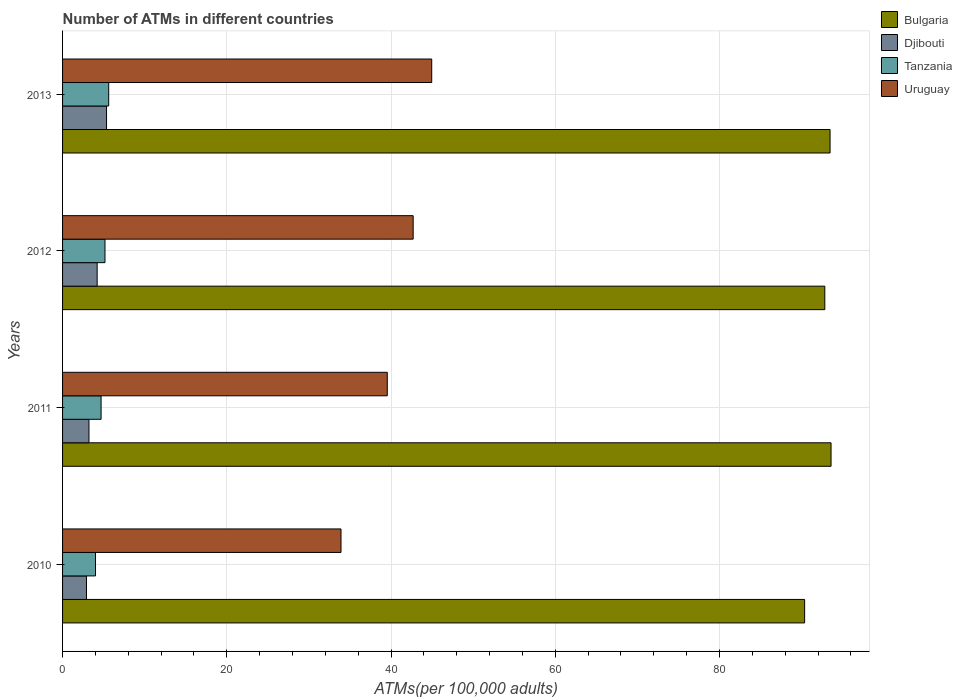How many different coloured bars are there?
Provide a short and direct response. 4. How many groups of bars are there?
Offer a very short reply. 4. Are the number of bars per tick equal to the number of legend labels?
Keep it short and to the point. Yes. What is the label of the 4th group of bars from the top?
Provide a short and direct response. 2010. What is the number of ATMs in Bulgaria in 2013?
Keep it short and to the point. 93.46. Across all years, what is the maximum number of ATMs in Bulgaria?
Make the answer very short. 93.58. Across all years, what is the minimum number of ATMs in Djibouti?
Offer a terse response. 2.91. In which year was the number of ATMs in Uruguay maximum?
Ensure brevity in your answer.  2013. In which year was the number of ATMs in Uruguay minimum?
Offer a terse response. 2010. What is the total number of ATMs in Djibouti in the graph?
Keep it short and to the point. 15.7. What is the difference between the number of ATMs in Djibouti in 2011 and that in 2012?
Make the answer very short. -1. What is the difference between the number of ATMs in Bulgaria in 2010 and the number of ATMs in Djibouti in 2011?
Your answer should be very brief. 87.15. What is the average number of ATMs in Tanzania per year?
Your answer should be compact. 4.87. In the year 2010, what is the difference between the number of ATMs in Bulgaria and number of ATMs in Djibouti?
Offer a very short reply. 87.45. In how many years, is the number of ATMs in Uruguay greater than 40 ?
Your answer should be very brief. 2. What is the ratio of the number of ATMs in Uruguay in 2012 to that in 2013?
Make the answer very short. 0.95. Is the number of ATMs in Bulgaria in 2012 less than that in 2013?
Keep it short and to the point. Yes. Is the difference between the number of ATMs in Bulgaria in 2012 and 2013 greater than the difference between the number of ATMs in Djibouti in 2012 and 2013?
Offer a terse response. Yes. What is the difference between the highest and the second highest number of ATMs in Bulgaria?
Offer a very short reply. 0.12. What is the difference between the highest and the lowest number of ATMs in Tanzania?
Offer a very short reply. 1.61. Is the sum of the number of ATMs in Tanzania in 2012 and 2013 greater than the maximum number of ATMs in Djibouti across all years?
Make the answer very short. Yes. Is it the case that in every year, the sum of the number of ATMs in Uruguay and number of ATMs in Djibouti is greater than the sum of number of ATMs in Bulgaria and number of ATMs in Tanzania?
Your answer should be very brief. Yes. What does the 1st bar from the top in 2013 represents?
Keep it short and to the point. Uruguay. How many bars are there?
Keep it short and to the point. 16. How many years are there in the graph?
Keep it short and to the point. 4. Are the values on the major ticks of X-axis written in scientific E-notation?
Offer a terse response. No. Where does the legend appear in the graph?
Make the answer very short. Top right. What is the title of the graph?
Offer a very short reply. Number of ATMs in different countries. What is the label or title of the X-axis?
Your response must be concise. ATMs(per 100,0 adults). What is the label or title of the Y-axis?
Make the answer very short. Years. What is the ATMs(per 100,000 adults) of Bulgaria in 2010?
Make the answer very short. 90.36. What is the ATMs(per 100,000 adults) of Djibouti in 2010?
Your response must be concise. 2.91. What is the ATMs(per 100,000 adults) in Tanzania in 2010?
Offer a very short reply. 4.01. What is the ATMs(per 100,000 adults) of Uruguay in 2010?
Offer a very short reply. 33.91. What is the ATMs(per 100,000 adults) of Bulgaria in 2011?
Give a very brief answer. 93.58. What is the ATMs(per 100,000 adults) of Djibouti in 2011?
Offer a very short reply. 3.21. What is the ATMs(per 100,000 adults) in Tanzania in 2011?
Your answer should be compact. 4.69. What is the ATMs(per 100,000 adults) of Uruguay in 2011?
Give a very brief answer. 39.54. What is the ATMs(per 100,000 adults) of Bulgaria in 2012?
Your response must be concise. 92.82. What is the ATMs(per 100,000 adults) in Djibouti in 2012?
Offer a terse response. 4.21. What is the ATMs(per 100,000 adults) of Tanzania in 2012?
Offer a terse response. 5.16. What is the ATMs(per 100,000 adults) in Uruguay in 2012?
Give a very brief answer. 42.69. What is the ATMs(per 100,000 adults) in Bulgaria in 2013?
Make the answer very short. 93.46. What is the ATMs(per 100,000 adults) in Djibouti in 2013?
Your answer should be very brief. 5.36. What is the ATMs(per 100,000 adults) of Tanzania in 2013?
Give a very brief answer. 5.62. What is the ATMs(per 100,000 adults) in Uruguay in 2013?
Your answer should be compact. 44.95. Across all years, what is the maximum ATMs(per 100,000 adults) in Bulgaria?
Your answer should be very brief. 93.58. Across all years, what is the maximum ATMs(per 100,000 adults) in Djibouti?
Your answer should be very brief. 5.36. Across all years, what is the maximum ATMs(per 100,000 adults) of Tanzania?
Make the answer very short. 5.62. Across all years, what is the maximum ATMs(per 100,000 adults) of Uruguay?
Provide a succinct answer. 44.95. Across all years, what is the minimum ATMs(per 100,000 adults) in Bulgaria?
Offer a very short reply. 90.36. Across all years, what is the minimum ATMs(per 100,000 adults) of Djibouti?
Your response must be concise. 2.91. Across all years, what is the minimum ATMs(per 100,000 adults) in Tanzania?
Your answer should be compact. 4.01. Across all years, what is the minimum ATMs(per 100,000 adults) in Uruguay?
Provide a short and direct response. 33.91. What is the total ATMs(per 100,000 adults) of Bulgaria in the graph?
Offer a terse response. 370.24. What is the total ATMs(per 100,000 adults) of Djibouti in the graph?
Provide a short and direct response. 15.7. What is the total ATMs(per 100,000 adults) in Tanzania in the graph?
Make the answer very short. 19.48. What is the total ATMs(per 100,000 adults) in Uruguay in the graph?
Your answer should be very brief. 161.1. What is the difference between the ATMs(per 100,000 adults) of Bulgaria in 2010 and that in 2011?
Offer a terse response. -3.22. What is the difference between the ATMs(per 100,000 adults) of Djibouti in 2010 and that in 2011?
Ensure brevity in your answer.  -0.3. What is the difference between the ATMs(per 100,000 adults) of Tanzania in 2010 and that in 2011?
Your answer should be very brief. -0.68. What is the difference between the ATMs(per 100,000 adults) in Uruguay in 2010 and that in 2011?
Make the answer very short. -5.64. What is the difference between the ATMs(per 100,000 adults) of Bulgaria in 2010 and that in 2012?
Offer a very short reply. -2.46. What is the difference between the ATMs(per 100,000 adults) in Djibouti in 2010 and that in 2012?
Provide a succinct answer. -1.3. What is the difference between the ATMs(per 100,000 adults) of Tanzania in 2010 and that in 2012?
Ensure brevity in your answer.  -1.15. What is the difference between the ATMs(per 100,000 adults) in Uruguay in 2010 and that in 2012?
Your answer should be very brief. -8.79. What is the difference between the ATMs(per 100,000 adults) of Bulgaria in 2010 and that in 2013?
Provide a short and direct response. -3.1. What is the difference between the ATMs(per 100,000 adults) in Djibouti in 2010 and that in 2013?
Provide a succinct answer. -2.44. What is the difference between the ATMs(per 100,000 adults) in Tanzania in 2010 and that in 2013?
Provide a succinct answer. -1.61. What is the difference between the ATMs(per 100,000 adults) of Uruguay in 2010 and that in 2013?
Provide a succinct answer. -11.05. What is the difference between the ATMs(per 100,000 adults) of Bulgaria in 2011 and that in 2012?
Provide a succinct answer. 0.76. What is the difference between the ATMs(per 100,000 adults) of Djibouti in 2011 and that in 2012?
Provide a succinct answer. -1. What is the difference between the ATMs(per 100,000 adults) in Tanzania in 2011 and that in 2012?
Offer a very short reply. -0.47. What is the difference between the ATMs(per 100,000 adults) in Uruguay in 2011 and that in 2012?
Provide a short and direct response. -3.15. What is the difference between the ATMs(per 100,000 adults) of Bulgaria in 2011 and that in 2013?
Your answer should be very brief. 0.12. What is the difference between the ATMs(per 100,000 adults) of Djibouti in 2011 and that in 2013?
Your answer should be very brief. -2.14. What is the difference between the ATMs(per 100,000 adults) of Tanzania in 2011 and that in 2013?
Give a very brief answer. -0.93. What is the difference between the ATMs(per 100,000 adults) in Uruguay in 2011 and that in 2013?
Make the answer very short. -5.41. What is the difference between the ATMs(per 100,000 adults) of Bulgaria in 2012 and that in 2013?
Provide a succinct answer. -0.64. What is the difference between the ATMs(per 100,000 adults) in Djibouti in 2012 and that in 2013?
Ensure brevity in your answer.  -1.14. What is the difference between the ATMs(per 100,000 adults) in Tanzania in 2012 and that in 2013?
Make the answer very short. -0.45. What is the difference between the ATMs(per 100,000 adults) in Uruguay in 2012 and that in 2013?
Your answer should be very brief. -2.26. What is the difference between the ATMs(per 100,000 adults) of Bulgaria in 2010 and the ATMs(per 100,000 adults) of Djibouti in 2011?
Give a very brief answer. 87.15. What is the difference between the ATMs(per 100,000 adults) in Bulgaria in 2010 and the ATMs(per 100,000 adults) in Tanzania in 2011?
Keep it short and to the point. 85.67. What is the difference between the ATMs(per 100,000 adults) of Bulgaria in 2010 and the ATMs(per 100,000 adults) of Uruguay in 2011?
Offer a terse response. 50.82. What is the difference between the ATMs(per 100,000 adults) in Djibouti in 2010 and the ATMs(per 100,000 adults) in Tanzania in 2011?
Your response must be concise. -1.78. What is the difference between the ATMs(per 100,000 adults) in Djibouti in 2010 and the ATMs(per 100,000 adults) in Uruguay in 2011?
Give a very brief answer. -36.63. What is the difference between the ATMs(per 100,000 adults) in Tanzania in 2010 and the ATMs(per 100,000 adults) in Uruguay in 2011?
Your answer should be very brief. -35.53. What is the difference between the ATMs(per 100,000 adults) of Bulgaria in 2010 and the ATMs(per 100,000 adults) of Djibouti in 2012?
Your answer should be very brief. 86.15. What is the difference between the ATMs(per 100,000 adults) in Bulgaria in 2010 and the ATMs(per 100,000 adults) in Tanzania in 2012?
Offer a terse response. 85.2. What is the difference between the ATMs(per 100,000 adults) of Bulgaria in 2010 and the ATMs(per 100,000 adults) of Uruguay in 2012?
Your response must be concise. 47.67. What is the difference between the ATMs(per 100,000 adults) in Djibouti in 2010 and the ATMs(per 100,000 adults) in Tanzania in 2012?
Offer a terse response. -2.25. What is the difference between the ATMs(per 100,000 adults) of Djibouti in 2010 and the ATMs(per 100,000 adults) of Uruguay in 2012?
Your answer should be compact. -39.78. What is the difference between the ATMs(per 100,000 adults) in Tanzania in 2010 and the ATMs(per 100,000 adults) in Uruguay in 2012?
Your answer should be very brief. -38.68. What is the difference between the ATMs(per 100,000 adults) of Bulgaria in 2010 and the ATMs(per 100,000 adults) of Djibouti in 2013?
Make the answer very short. 85.01. What is the difference between the ATMs(per 100,000 adults) in Bulgaria in 2010 and the ATMs(per 100,000 adults) in Tanzania in 2013?
Provide a short and direct response. 84.75. What is the difference between the ATMs(per 100,000 adults) of Bulgaria in 2010 and the ATMs(per 100,000 adults) of Uruguay in 2013?
Your response must be concise. 45.41. What is the difference between the ATMs(per 100,000 adults) in Djibouti in 2010 and the ATMs(per 100,000 adults) in Tanzania in 2013?
Your response must be concise. -2.71. What is the difference between the ATMs(per 100,000 adults) in Djibouti in 2010 and the ATMs(per 100,000 adults) in Uruguay in 2013?
Make the answer very short. -42.04. What is the difference between the ATMs(per 100,000 adults) of Tanzania in 2010 and the ATMs(per 100,000 adults) of Uruguay in 2013?
Make the answer very short. -40.94. What is the difference between the ATMs(per 100,000 adults) in Bulgaria in 2011 and the ATMs(per 100,000 adults) in Djibouti in 2012?
Give a very brief answer. 89.37. What is the difference between the ATMs(per 100,000 adults) of Bulgaria in 2011 and the ATMs(per 100,000 adults) of Tanzania in 2012?
Give a very brief answer. 88.42. What is the difference between the ATMs(per 100,000 adults) in Bulgaria in 2011 and the ATMs(per 100,000 adults) in Uruguay in 2012?
Offer a terse response. 50.89. What is the difference between the ATMs(per 100,000 adults) in Djibouti in 2011 and the ATMs(per 100,000 adults) in Tanzania in 2012?
Give a very brief answer. -1.95. What is the difference between the ATMs(per 100,000 adults) in Djibouti in 2011 and the ATMs(per 100,000 adults) in Uruguay in 2012?
Keep it short and to the point. -39.48. What is the difference between the ATMs(per 100,000 adults) of Tanzania in 2011 and the ATMs(per 100,000 adults) of Uruguay in 2012?
Your answer should be very brief. -38. What is the difference between the ATMs(per 100,000 adults) of Bulgaria in 2011 and the ATMs(per 100,000 adults) of Djibouti in 2013?
Your answer should be compact. 88.23. What is the difference between the ATMs(per 100,000 adults) in Bulgaria in 2011 and the ATMs(per 100,000 adults) in Tanzania in 2013?
Offer a very short reply. 87.97. What is the difference between the ATMs(per 100,000 adults) in Bulgaria in 2011 and the ATMs(per 100,000 adults) in Uruguay in 2013?
Make the answer very short. 48.63. What is the difference between the ATMs(per 100,000 adults) of Djibouti in 2011 and the ATMs(per 100,000 adults) of Tanzania in 2013?
Ensure brevity in your answer.  -2.4. What is the difference between the ATMs(per 100,000 adults) in Djibouti in 2011 and the ATMs(per 100,000 adults) in Uruguay in 2013?
Your response must be concise. -41.74. What is the difference between the ATMs(per 100,000 adults) in Tanzania in 2011 and the ATMs(per 100,000 adults) in Uruguay in 2013?
Make the answer very short. -40.26. What is the difference between the ATMs(per 100,000 adults) of Bulgaria in 2012 and the ATMs(per 100,000 adults) of Djibouti in 2013?
Offer a very short reply. 87.47. What is the difference between the ATMs(per 100,000 adults) of Bulgaria in 2012 and the ATMs(per 100,000 adults) of Tanzania in 2013?
Ensure brevity in your answer.  87.21. What is the difference between the ATMs(per 100,000 adults) in Bulgaria in 2012 and the ATMs(per 100,000 adults) in Uruguay in 2013?
Provide a succinct answer. 47.87. What is the difference between the ATMs(per 100,000 adults) in Djibouti in 2012 and the ATMs(per 100,000 adults) in Tanzania in 2013?
Provide a succinct answer. -1.41. What is the difference between the ATMs(per 100,000 adults) of Djibouti in 2012 and the ATMs(per 100,000 adults) of Uruguay in 2013?
Offer a very short reply. -40.74. What is the difference between the ATMs(per 100,000 adults) of Tanzania in 2012 and the ATMs(per 100,000 adults) of Uruguay in 2013?
Make the answer very short. -39.79. What is the average ATMs(per 100,000 adults) in Bulgaria per year?
Keep it short and to the point. 92.56. What is the average ATMs(per 100,000 adults) of Djibouti per year?
Your answer should be very brief. 3.92. What is the average ATMs(per 100,000 adults) in Tanzania per year?
Give a very brief answer. 4.87. What is the average ATMs(per 100,000 adults) in Uruguay per year?
Your response must be concise. 40.27. In the year 2010, what is the difference between the ATMs(per 100,000 adults) in Bulgaria and ATMs(per 100,000 adults) in Djibouti?
Your answer should be compact. 87.45. In the year 2010, what is the difference between the ATMs(per 100,000 adults) of Bulgaria and ATMs(per 100,000 adults) of Tanzania?
Provide a short and direct response. 86.35. In the year 2010, what is the difference between the ATMs(per 100,000 adults) in Bulgaria and ATMs(per 100,000 adults) in Uruguay?
Provide a short and direct response. 56.46. In the year 2010, what is the difference between the ATMs(per 100,000 adults) of Djibouti and ATMs(per 100,000 adults) of Tanzania?
Offer a very short reply. -1.1. In the year 2010, what is the difference between the ATMs(per 100,000 adults) of Djibouti and ATMs(per 100,000 adults) of Uruguay?
Make the answer very short. -30.99. In the year 2010, what is the difference between the ATMs(per 100,000 adults) of Tanzania and ATMs(per 100,000 adults) of Uruguay?
Your response must be concise. -29.9. In the year 2011, what is the difference between the ATMs(per 100,000 adults) of Bulgaria and ATMs(per 100,000 adults) of Djibouti?
Ensure brevity in your answer.  90.37. In the year 2011, what is the difference between the ATMs(per 100,000 adults) of Bulgaria and ATMs(per 100,000 adults) of Tanzania?
Your response must be concise. 88.89. In the year 2011, what is the difference between the ATMs(per 100,000 adults) in Bulgaria and ATMs(per 100,000 adults) in Uruguay?
Provide a succinct answer. 54.04. In the year 2011, what is the difference between the ATMs(per 100,000 adults) of Djibouti and ATMs(per 100,000 adults) of Tanzania?
Make the answer very short. -1.48. In the year 2011, what is the difference between the ATMs(per 100,000 adults) in Djibouti and ATMs(per 100,000 adults) in Uruguay?
Offer a terse response. -36.33. In the year 2011, what is the difference between the ATMs(per 100,000 adults) in Tanzania and ATMs(per 100,000 adults) in Uruguay?
Give a very brief answer. -34.85. In the year 2012, what is the difference between the ATMs(per 100,000 adults) in Bulgaria and ATMs(per 100,000 adults) in Djibouti?
Your answer should be very brief. 88.61. In the year 2012, what is the difference between the ATMs(per 100,000 adults) of Bulgaria and ATMs(per 100,000 adults) of Tanzania?
Ensure brevity in your answer.  87.66. In the year 2012, what is the difference between the ATMs(per 100,000 adults) of Bulgaria and ATMs(per 100,000 adults) of Uruguay?
Ensure brevity in your answer.  50.13. In the year 2012, what is the difference between the ATMs(per 100,000 adults) of Djibouti and ATMs(per 100,000 adults) of Tanzania?
Your answer should be very brief. -0.95. In the year 2012, what is the difference between the ATMs(per 100,000 adults) of Djibouti and ATMs(per 100,000 adults) of Uruguay?
Give a very brief answer. -38.48. In the year 2012, what is the difference between the ATMs(per 100,000 adults) of Tanzania and ATMs(per 100,000 adults) of Uruguay?
Provide a succinct answer. -37.53. In the year 2013, what is the difference between the ATMs(per 100,000 adults) of Bulgaria and ATMs(per 100,000 adults) of Djibouti?
Give a very brief answer. 88.11. In the year 2013, what is the difference between the ATMs(per 100,000 adults) of Bulgaria and ATMs(per 100,000 adults) of Tanzania?
Keep it short and to the point. 87.85. In the year 2013, what is the difference between the ATMs(per 100,000 adults) in Bulgaria and ATMs(per 100,000 adults) in Uruguay?
Keep it short and to the point. 48.51. In the year 2013, what is the difference between the ATMs(per 100,000 adults) of Djibouti and ATMs(per 100,000 adults) of Tanzania?
Ensure brevity in your answer.  -0.26. In the year 2013, what is the difference between the ATMs(per 100,000 adults) of Djibouti and ATMs(per 100,000 adults) of Uruguay?
Offer a very short reply. -39.6. In the year 2013, what is the difference between the ATMs(per 100,000 adults) in Tanzania and ATMs(per 100,000 adults) in Uruguay?
Offer a very short reply. -39.34. What is the ratio of the ATMs(per 100,000 adults) in Bulgaria in 2010 to that in 2011?
Your answer should be compact. 0.97. What is the ratio of the ATMs(per 100,000 adults) in Djibouti in 2010 to that in 2011?
Ensure brevity in your answer.  0.91. What is the ratio of the ATMs(per 100,000 adults) of Tanzania in 2010 to that in 2011?
Provide a succinct answer. 0.86. What is the ratio of the ATMs(per 100,000 adults) of Uruguay in 2010 to that in 2011?
Your answer should be compact. 0.86. What is the ratio of the ATMs(per 100,000 adults) in Bulgaria in 2010 to that in 2012?
Your answer should be compact. 0.97. What is the ratio of the ATMs(per 100,000 adults) of Djibouti in 2010 to that in 2012?
Your answer should be compact. 0.69. What is the ratio of the ATMs(per 100,000 adults) of Tanzania in 2010 to that in 2012?
Give a very brief answer. 0.78. What is the ratio of the ATMs(per 100,000 adults) of Uruguay in 2010 to that in 2012?
Make the answer very short. 0.79. What is the ratio of the ATMs(per 100,000 adults) in Bulgaria in 2010 to that in 2013?
Make the answer very short. 0.97. What is the ratio of the ATMs(per 100,000 adults) of Djibouti in 2010 to that in 2013?
Give a very brief answer. 0.54. What is the ratio of the ATMs(per 100,000 adults) in Tanzania in 2010 to that in 2013?
Your answer should be compact. 0.71. What is the ratio of the ATMs(per 100,000 adults) in Uruguay in 2010 to that in 2013?
Ensure brevity in your answer.  0.75. What is the ratio of the ATMs(per 100,000 adults) in Bulgaria in 2011 to that in 2012?
Make the answer very short. 1.01. What is the ratio of the ATMs(per 100,000 adults) of Djibouti in 2011 to that in 2012?
Make the answer very short. 0.76. What is the ratio of the ATMs(per 100,000 adults) in Tanzania in 2011 to that in 2012?
Ensure brevity in your answer.  0.91. What is the ratio of the ATMs(per 100,000 adults) in Uruguay in 2011 to that in 2012?
Make the answer very short. 0.93. What is the ratio of the ATMs(per 100,000 adults) in Djibouti in 2011 to that in 2013?
Offer a very short reply. 0.6. What is the ratio of the ATMs(per 100,000 adults) in Tanzania in 2011 to that in 2013?
Your answer should be very brief. 0.83. What is the ratio of the ATMs(per 100,000 adults) of Uruguay in 2011 to that in 2013?
Provide a succinct answer. 0.88. What is the ratio of the ATMs(per 100,000 adults) of Bulgaria in 2012 to that in 2013?
Keep it short and to the point. 0.99. What is the ratio of the ATMs(per 100,000 adults) in Djibouti in 2012 to that in 2013?
Offer a terse response. 0.79. What is the ratio of the ATMs(per 100,000 adults) of Tanzania in 2012 to that in 2013?
Offer a terse response. 0.92. What is the ratio of the ATMs(per 100,000 adults) in Uruguay in 2012 to that in 2013?
Your response must be concise. 0.95. What is the difference between the highest and the second highest ATMs(per 100,000 adults) of Bulgaria?
Provide a short and direct response. 0.12. What is the difference between the highest and the second highest ATMs(per 100,000 adults) in Djibouti?
Keep it short and to the point. 1.14. What is the difference between the highest and the second highest ATMs(per 100,000 adults) in Tanzania?
Keep it short and to the point. 0.45. What is the difference between the highest and the second highest ATMs(per 100,000 adults) of Uruguay?
Keep it short and to the point. 2.26. What is the difference between the highest and the lowest ATMs(per 100,000 adults) in Bulgaria?
Offer a very short reply. 3.22. What is the difference between the highest and the lowest ATMs(per 100,000 adults) of Djibouti?
Your response must be concise. 2.44. What is the difference between the highest and the lowest ATMs(per 100,000 adults) in Tanzania?
Offer a terse response. 1.61. What is the difference between the highest and the lowest ATMs(per 100,000 adults) of Uruguay?
Make the answer very short. 11.05. 